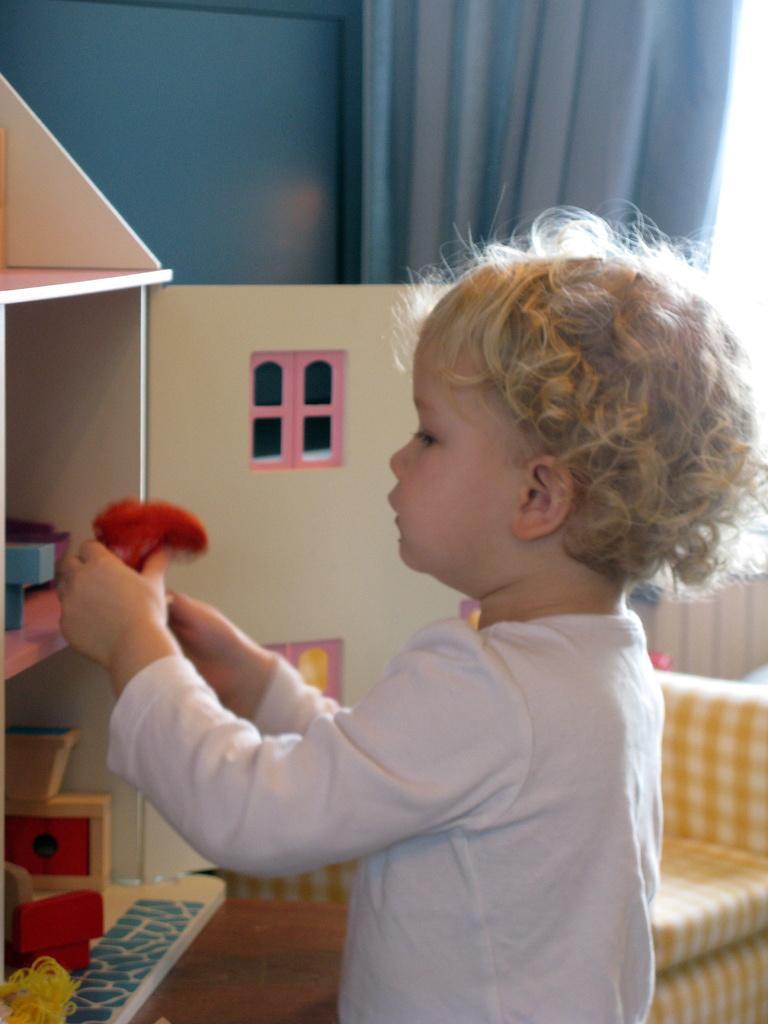Could you give a brief overview of what you see in this image? There is a child holding something in the hand. In front of the child there is a cupboard. Inside the cupboard there are many items. In the back there is sofa. In the background there is a curtain. 